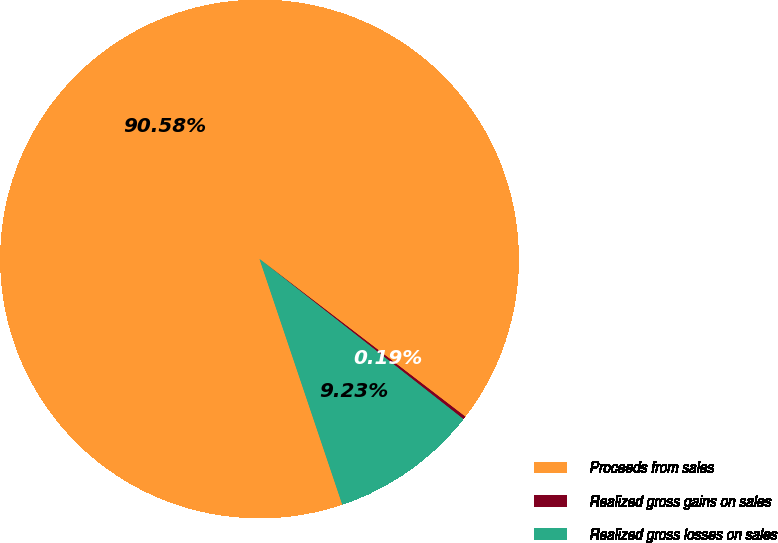Convert chart. <chart><loc_0><loc_0><loc_500><loc_500><pie_chart><fcel>Proceeds from sales<fcel>Realized gross gains on sales<fcel>Realized gross losses on sales<nl><fcel>90.58%<fcel>0.19%<fcel>9.23%<nl></chart> 